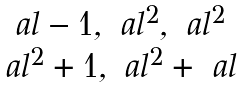Convert formula to latex. <formula><loc_0><loc_0><loc_500><loc_500>\begin{matrix} \ a l - 1 , \ a l ^ { 2 } , \ a l ^ { 2 } \\ \ a l ^ { 2 } + 1 , \ a l ^ { 2 } + \ a l \end{matrix}</formula> 